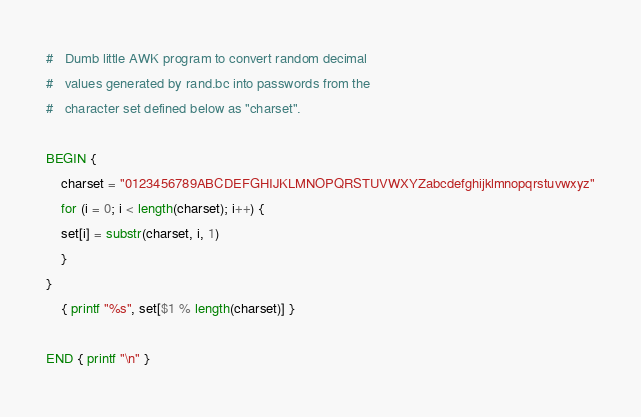Convert code to text. <code><loc_0><loc_0><loc_500><loc_500><_Awk_>
#   Dumb little AWK program to convert random decimal
#   values generated by rand.bc into passwords from the
#   character set defined below as "charset".

BEGIN {
    charset = "0123456789ABCDEFGHIJKLMNOPQRSTUVWXYZabcdefghijklmnopqrstuvwxyz"
    for (i = 0; i < length(charset); i++) {
	set[i] = substr(charset, i, 1)
    }
}
    { printf "%s", set[$1 % length(charset)] }

END { printf "\n" }
</code> 